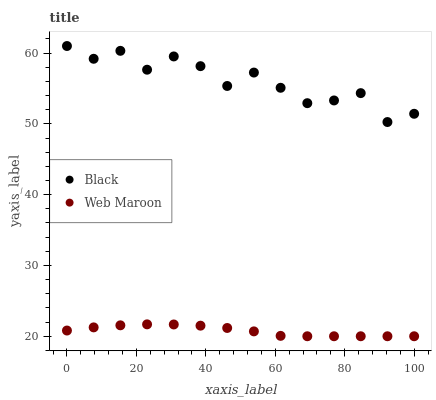Does Web Maroon have the minimum area under the curve?
Answer yes or no. Yes. Does Black have the maximum area under the curve?
Answer yes or no. Yes. Does Black have the minimum area under the curve?
Answer yes or no. No. Is Web Maroon the smoothest?
Answer yes or no. Yes. Is Black the roughest?
Answer yes or no. Yes. Is Black the smoothest?
Answer yes or no. No. Does Web Maroon have the lowest value?
Answer yes or no. Yes. Does Black have the lowest value?
Answer yes or no. No. Does Black have the highest value?
Answer yes or no. Yes. Is Web Maroon less than Black?
Answer yes or no. Yes. Is Black greater than Web Maroon?
Answer yes or no. Yes. Does Web Maroon intersect Black?
Answer yes or no. No. 